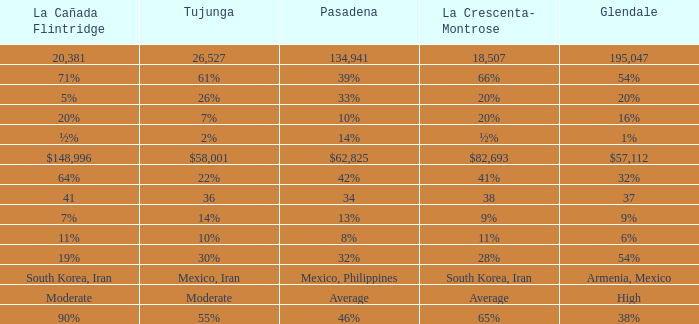What is the figure for Tujunga when Pasadena is 134,941? 26527.0. 